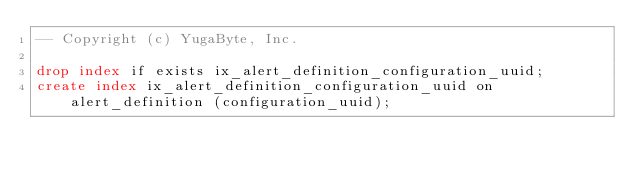Convert code to text. <code><loc_0><loc_0><loc_500><loc_500><_SQL_>-- Copyright (c) YugaByte, Inc.

drop index if exists ix_alert_definition_configuration_uuid;
create index ix_alert_definition_configuration_uuid on alert_definition (configuration_uuid);
</code> 